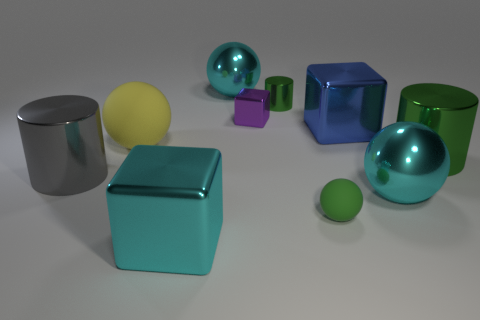How many green cylinders must be subtracted to get 1 green cylinders? 1 Subtract all large shiny cubes. How many cubes are left? 1 Subtract all cyan balls. How many green cylinders are left? 2 Subtract all green spheres. How many spheres are left? 3 Subtract 1 cylinders. How many cylinders are left? 2 Subtract all cubes. How many objects are left? 7 Subtract all gray balls. Subtract all red blocks. How many balls are left? 4 Subtract all large yellow rubber objects. Subtract all small red metal cylinders. How many objects are left? 9 Add 8 cyan metal balls. How many cyan metal balls are left? 10 Add 8 cyan shiny cubes. How many cyan shiny cubes exist? 9 